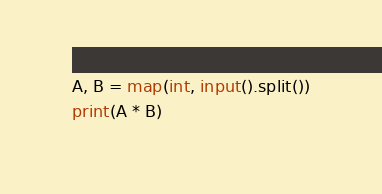Convert code to text. <code><loc_0><loc_0><loc_500><loc_500><_Python_>A, B = map(int, input().split())
print(A * B)

</code> 